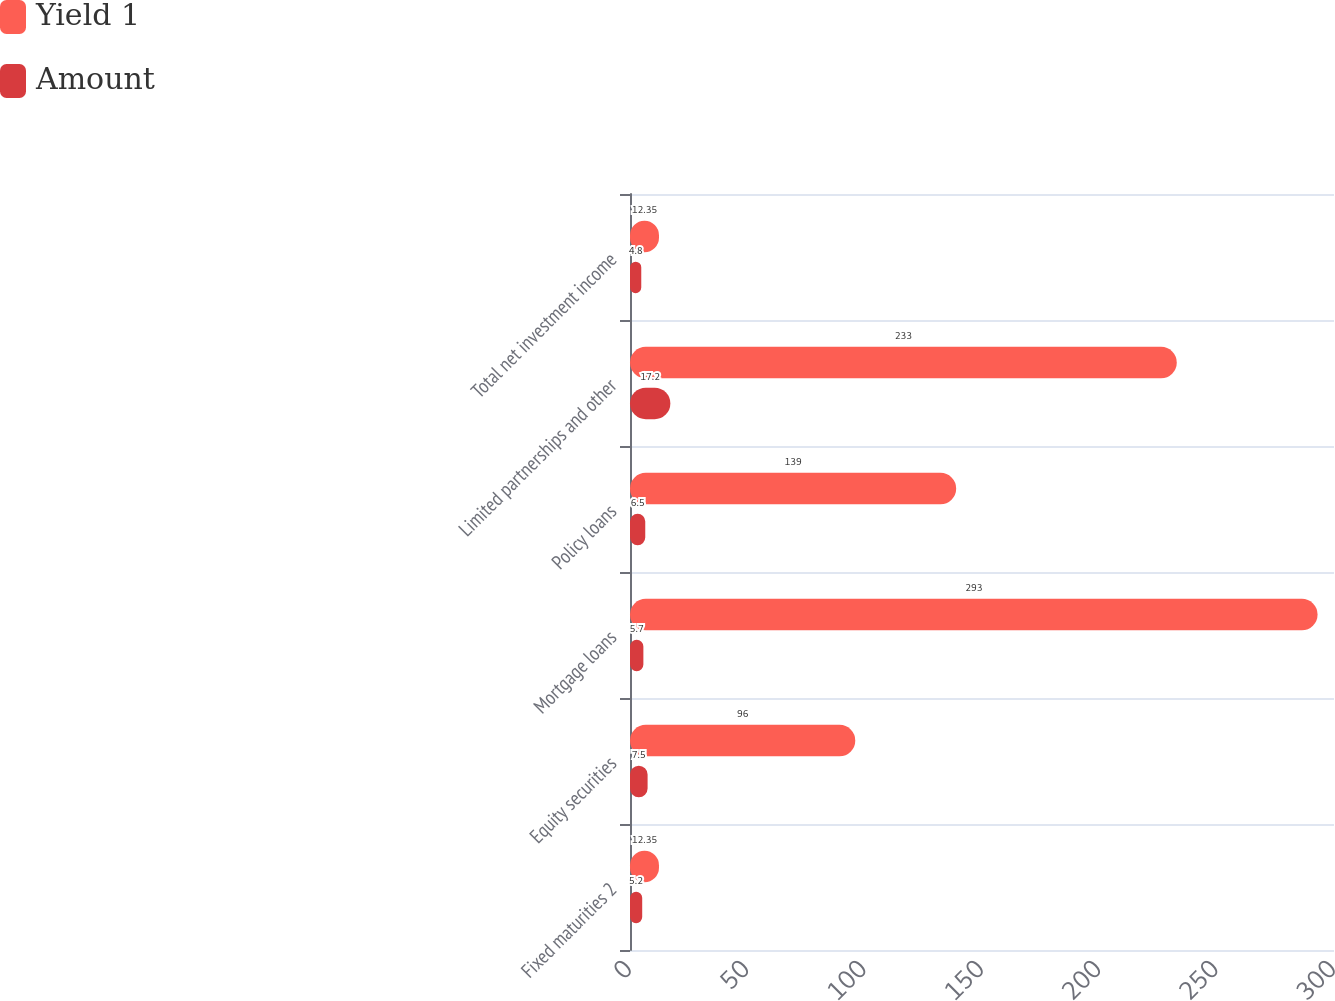Convert chart to OTSL. <chart><loc_0><loc_0><loc_500><loc_500><stacked_bar_chart><ecel><fcel>Fixed maturities 2<fcel>Equity securities<fcel>Mortgage loans<fcel>Policy loans<fcel>Limited partnerships and other<fcel>Total net investment income<nl><fcel>Yield 1<fcel>12.35<fcel>96<fcel>293<fcel>139<fcel>233<fcel>12.35<nl><fcel>Amount<fcel>5.2<fcel>7.5<fcel>5.7<fcel>6.5<fcel>17.2<fcel>4.8<nl></chart> 